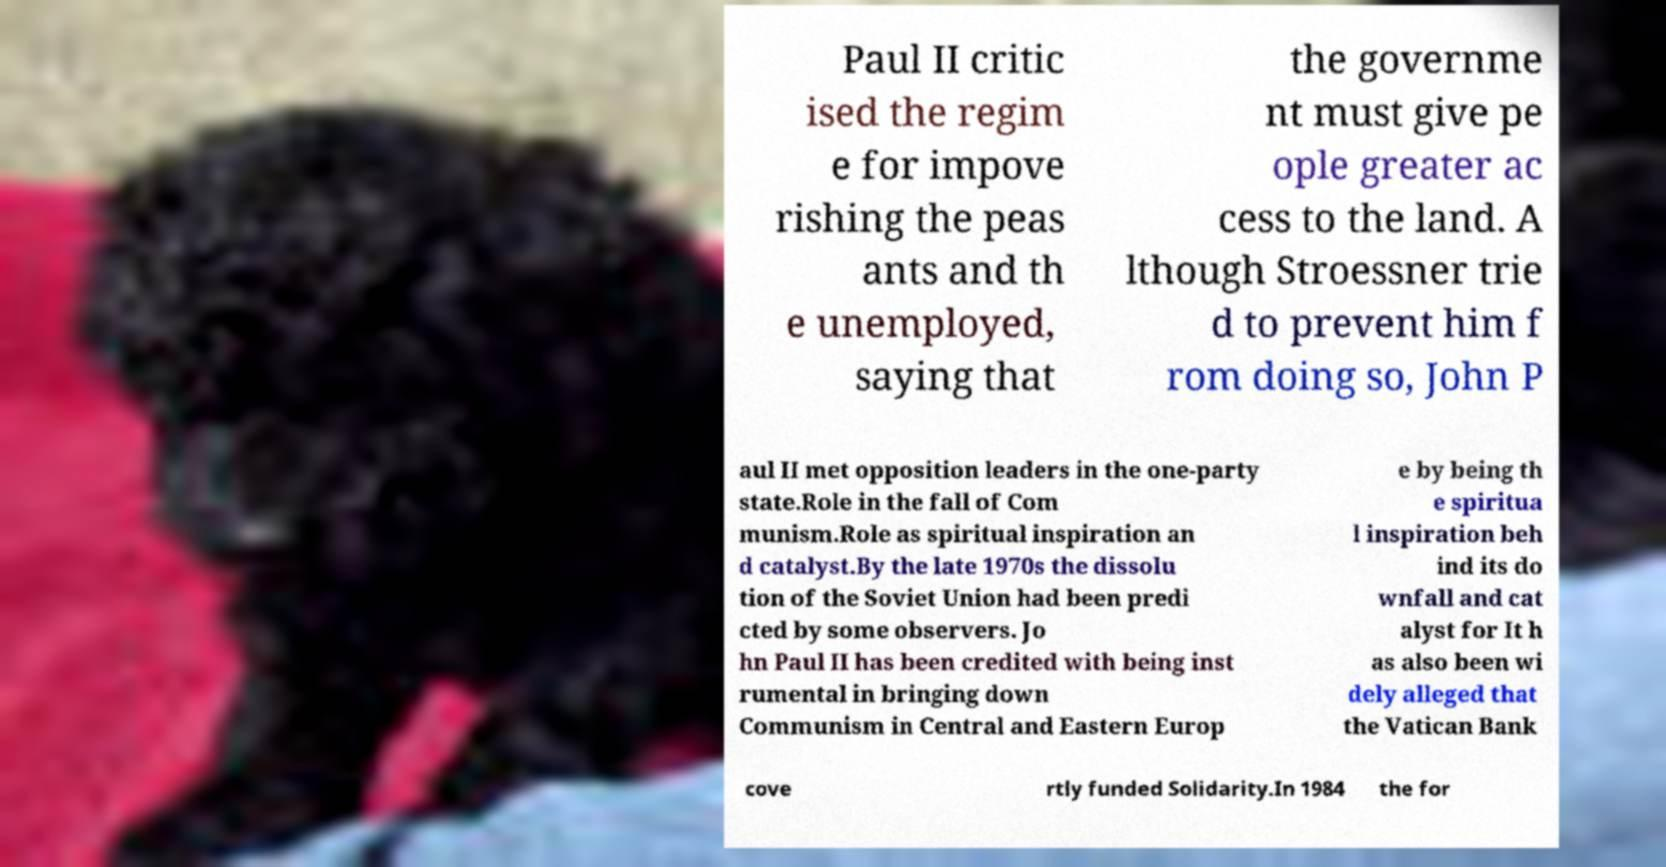I need the written content from this picture converted into text. Can you do that? Paul II critic ised the regim e for impove rishing the peas ants and th e unemployed, saying that the governme nt must give pe ople greater ac cess to the land. A lthough Stroessner trie d to prevent him f rom doing so, John P aul II met opposition leaders in the one-party state.Role in the fall of Com munism.Role as spiritual inspiration an d catalyst.By the late 1970s the dissolu tion of the Soviet Union had been predi cted by some observers. Jo hn Paul II has been credited with being inst rumental in bringing down Communism in Central and Eastern Europ e by being th e spiritua l inspiration beh ind its do wnfall and cat alyst for It h as also been wi dely alleged that the Vatican Bank cove rtly funded Solidarity.In 1984 the for 